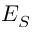<formula> <loc_0><loc_0><loc_500><loc_500>E _ { S }</formula> 